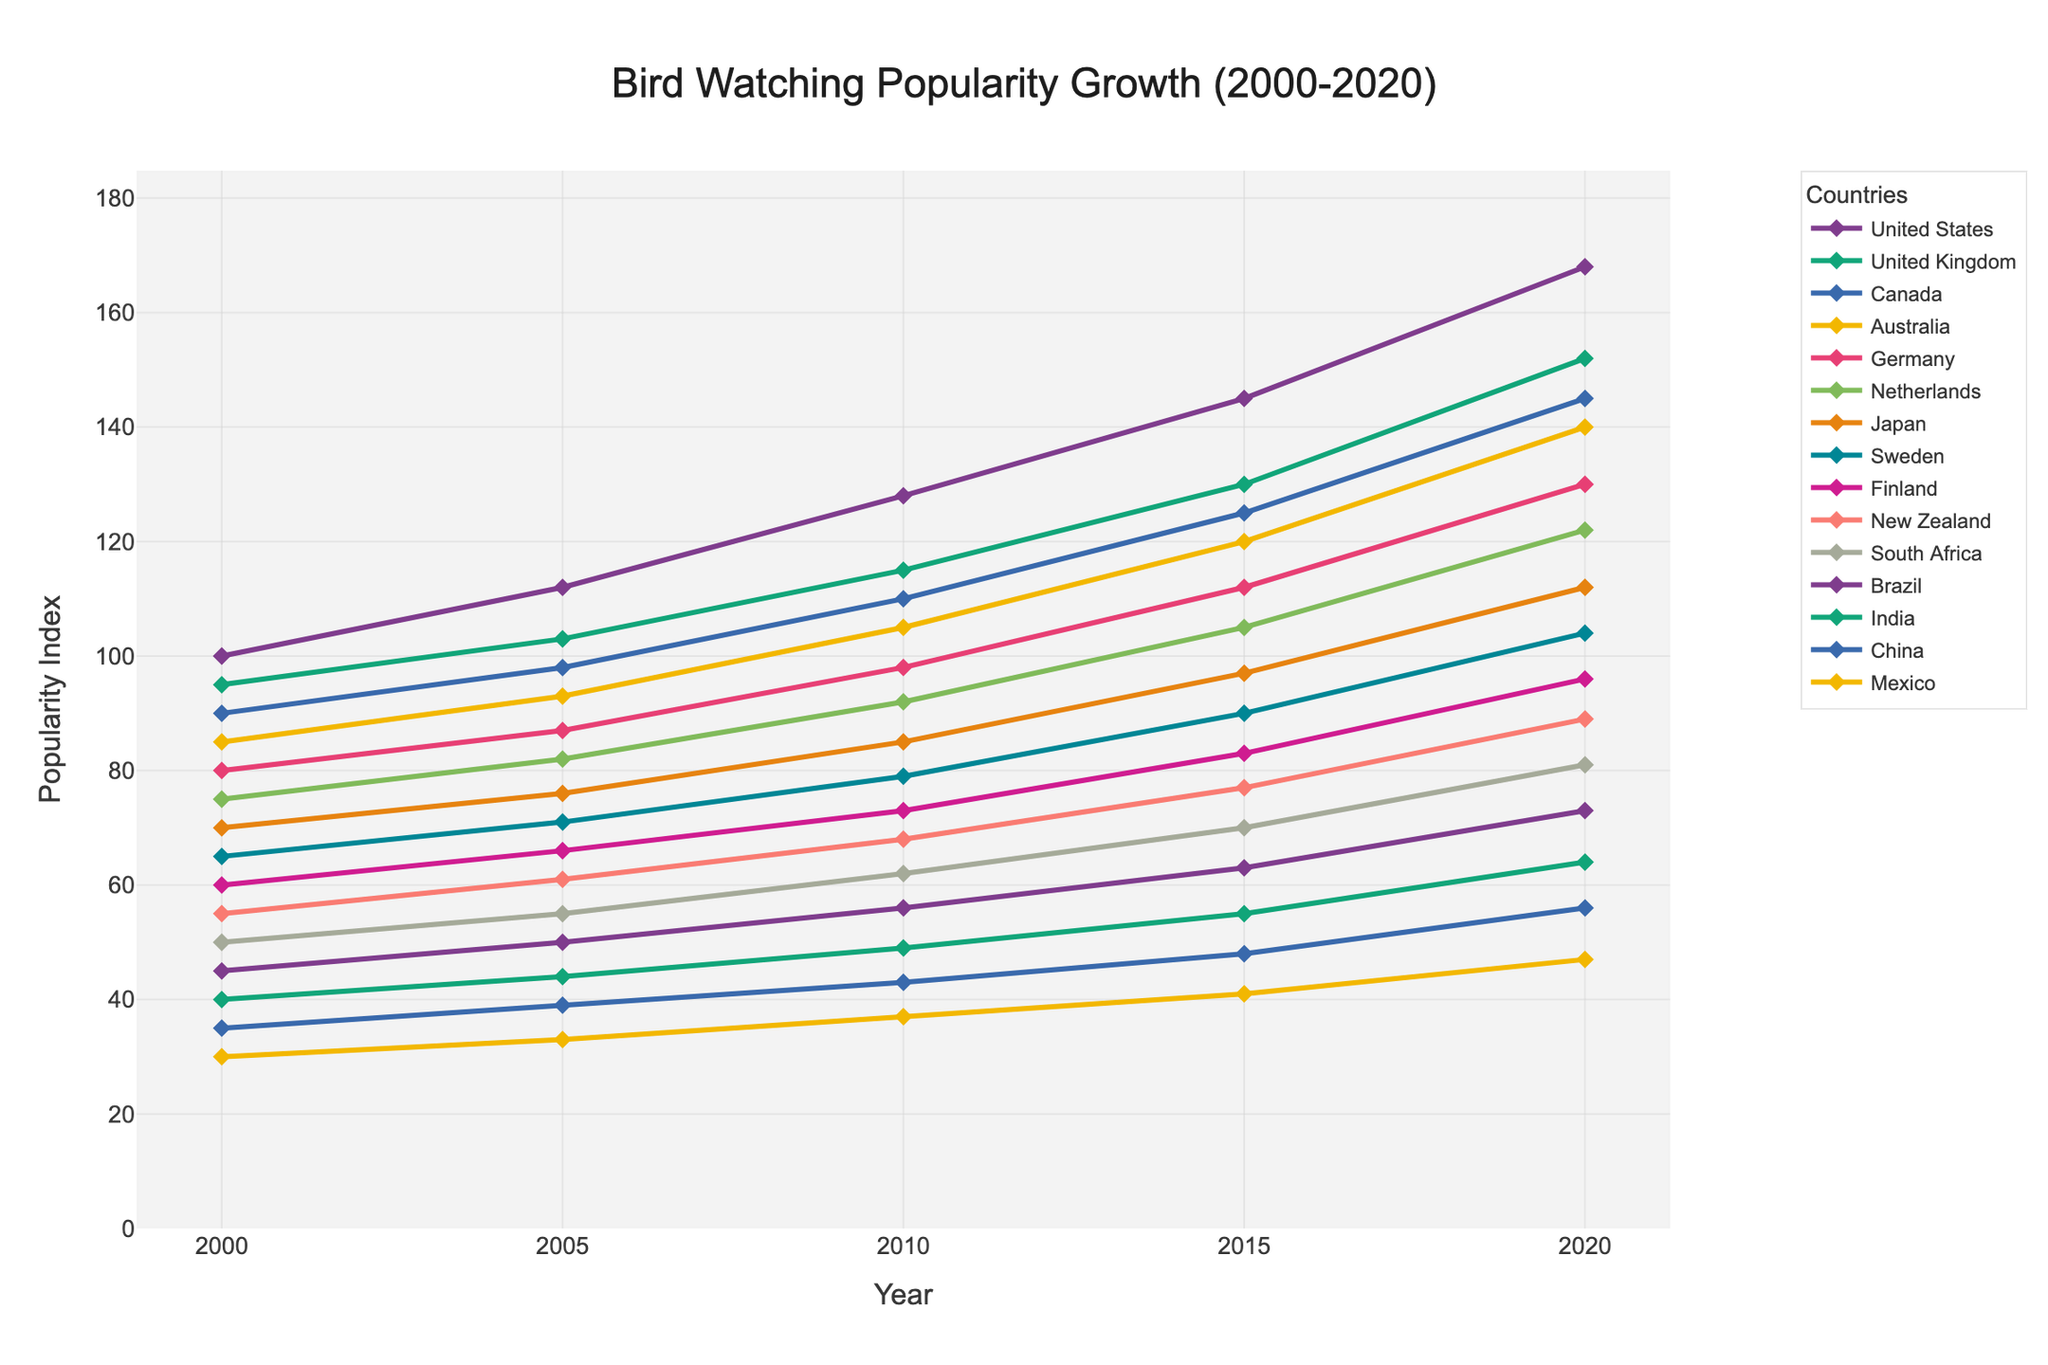Which country shows the highest increase in the popularity index from 2000 to 2020? By examining the line chart, identify the highest endpoint on the y-axis in 2020. Compare it with the values in 2000 to determine the total increase over the period for each country. The United States shows the highest increase, starting from 100 to 168, yielding an increase of 68.
Answer: United States What is the average popularity index for Canada in the given years? Calculate the average by summing the popularity indices for Canada for all given years and dividing by the number of years: (90 + 98 + 110 + 125 + 145)/5.
Answer: 113.6 Which country had the least popularity index in 2010? Look at the 2010 markers on the chart and identify the lowest point. In 2010, Mexico had the least popularity index with 37.
Answer: Mexico How does the popularity index growth of Sweden compare to that of Brazil over 20 years? Calculate the difference in popularity indices from 2000 to 2020 for both Sweden and Brazil: Sweden's increase (104 - 65 = 39), Brazil's increase (73 - 45 = 28). Sweden shows a larger increase.
Answer: Sweden has a higher growth rate than Brazil Which country’s popularity index in 2020 is closest to 100? Locate the 2020 values on the y-axis and find the closest point to 100. Finland's 2020 index is 96, which is closest to 100.
Answer: Finland Which two countries have the most similar trends in popularity growth? Observe the lines for similar slope and shape over the years. The United Kingdom and Canada show closely similar trends, parallel and increasing at almost the same rate.
Answer: United Kingdom and Canada By how much did the popularity index of India change from 2005 to 2015? Identify India's indices in 2005 and 2015, then calculate the difference: 55 - 44 = 11.
Answer: 11 Which countries have an index greater than 120 in 2020? Identify all lines that cross the 120 mark on the y-axis in 2020. These countries are United States, United Kingdom, Canada, Australia, and Germany.
Answer: United States, United Kingdom, Canada, Australia, Germany What is the combined popularity index for Japan and South Africa in 2020? Sum up the 2020 values for Japan (112) and South Africa (81): 112 + 81 = 193.
Answer: 193 Which country saw the smallest increase in the popularity index from 2000-2020? Compare the 2000 and 2020 values and calculate the increase for each country. China saw the smallest increase, 56 - 35 = 21.
Answer: China 